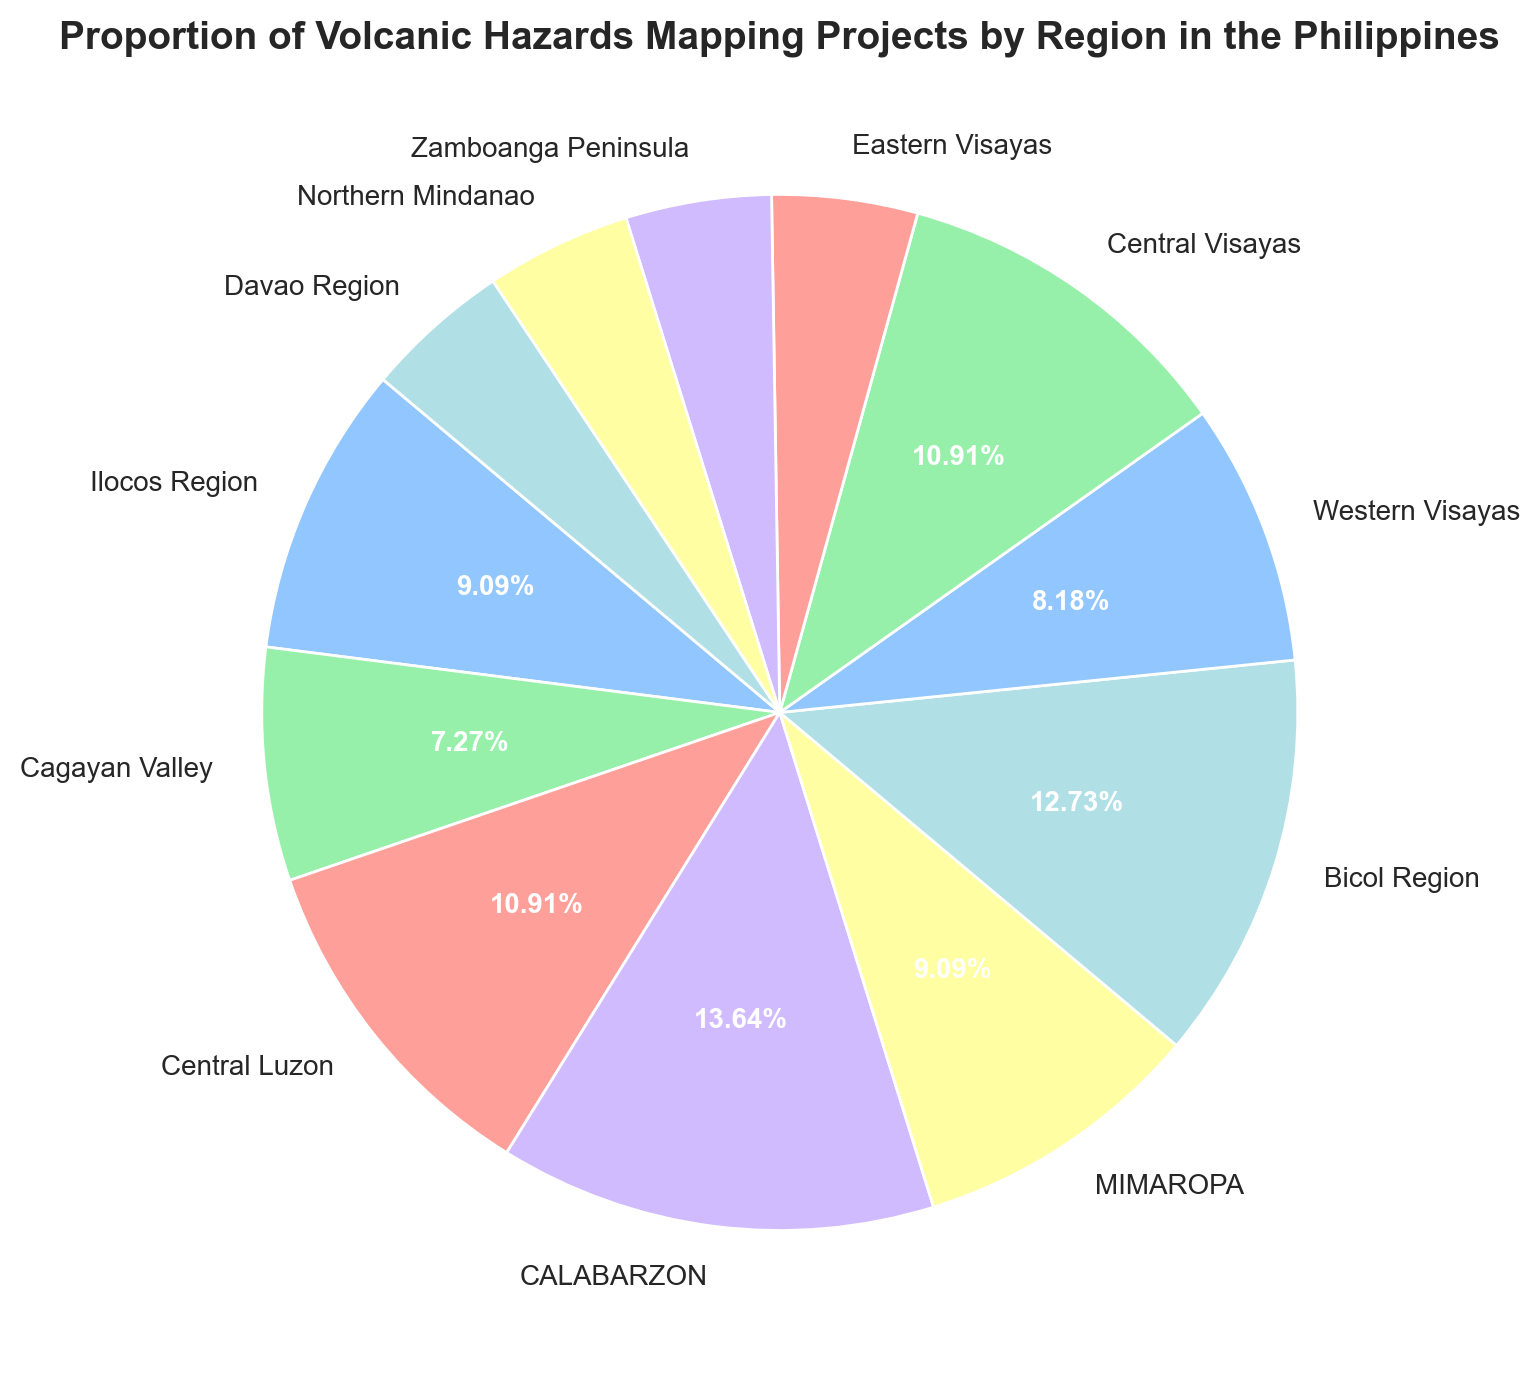what region has the highest proportion of volcanic hazards mapping projects? By visually inspecting the pie chart, we can see that CALABARZON has the largest wedge, indicating it has the highest proportion of volcanic hazards mapping projects.
Answer: CALABARZON Which region has a higher proportion of volcanic hazards mapping projects, Ilocos Region or Central Luzon? From the pie chart, we observe that the wedge for Central Luzon is larger than the wedge for Ilocos Region. Therefore, Central Luzon has a higher proportion.
Answer: Central Luzon What is the combined proportion of volcanic hazards mapping projects for Central Luzon and Central Visayas? According to the chart, Central Luzon has a proportion of 12% and Central Visayas also has 12%. Adding these proportions: 12% + 12% = 24%.
Answer: 24% Which regions have an equal proportion of volcanic hazards mapping projects? From the pie chart, the regions with equal wedges are Eastern Visayas, Zamboanga Peninsula, Northern Mindanao, and Davao Region, each having 5%.
Answer: Eastern Visayas, Zamboanga Peninsula, Northern Mindanao, Davao Region Which region contributes approximately one-seventh to the total volcanic hazards mapping projects? We need to identify which region's proportion is about 1/7 or ~14.3%. Bicol Region, with a proportion of 14%, is closest to this value.
Answer: Bicol Region What is the difference in proportion between CALABARZON and Western Visayas? CALABARZON has a proportion of 15%, and Western Visayas has 9%. The difference is 15% - 9% = 6%.
Answer: 6% What is the total proportion of volcanic hazards mapping projects for regions in the Mindanao area? The relevant regions are Northern Mindanao, Zamboanga Peninsula, and Davao Region, each having a proportion of 5%. The total is 5% + 5% + 5% = 15%.
Answer: 15% If you combine the proportions for Ilocos Region and MIMAROPA, how do they compare to the proportion for CALABARZON? Ilocos Region has 10%, and MIMAROPA also has 10% giving a combined total of 20%. CALABARZON has 15%. Thus, their combined proportion is higher than that of CALABARZON.
Answer: Higher What is the average proportion of volcanic hazards mapping projects for Eastern Visayas, Zamboanga Peninsula, Northern Mindanao, and Davao Region? These regions each have 5%. The average proportion is calculated as (5% + 5% + 5% + 5%) / 4 = 5%.
Answer: 5% Which visual aspect helps to identify different regions in the pie chart? The pie chart segments (wedges) each labeled with the region name help identify different regions. Additionally, the sizes of these wedges represent the proportions.
Answer: Segment labels and sizes 